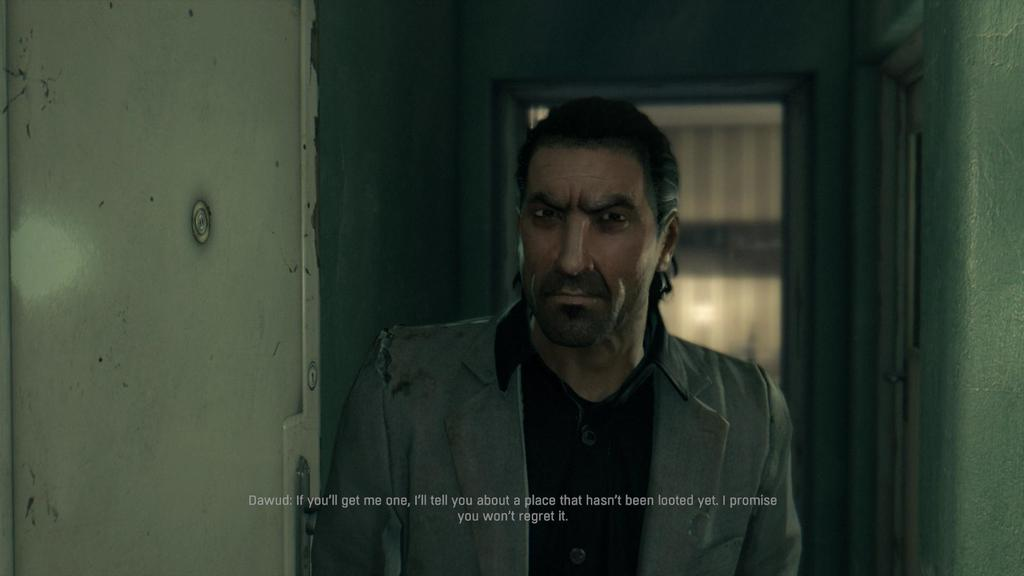What can be found at the bottom of the image? There is text at the bottom of the image. What is located on the left side of the image? There is a wall on the left side of the image. What is on the opposite side of the image? There is another wall on the right side of the image. Can you describe the background of the image? There is a door in the background of the image. What type of quartz can be seen in the throat of the person in the image? There is no person or quartz present in the image. Are there any police officers visible in the image? There are no police officers present in the image. 